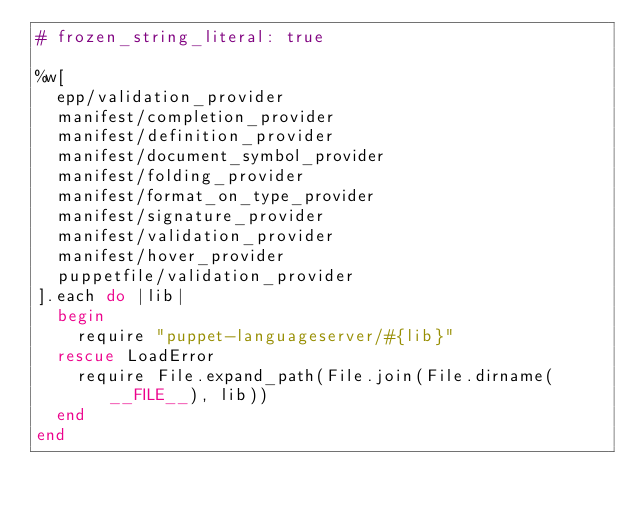Convert code to text. <code><loc_0><loc_0><loc_500><loc_500><_Ruby_># frozen_string_literal: true

%w[
  epp/validation_provider
  manifest/completion_provider
  manifest/definition_provider
  manifest/document_symbol_provider
  manifest/folding_provider
  manifest/format_on_type_provider
  manifest/signature_provider
  manifest/validation_provider
  manifest/hover_provider
  puppetfile/validation_provider
].each do |lib|
  begin
    require "puppet-languageserver/#{lib}"
  rescue LoadError
    require File.expand_path(File.join(File.dirname(__FILE__), lib))
  end
end
</code> 